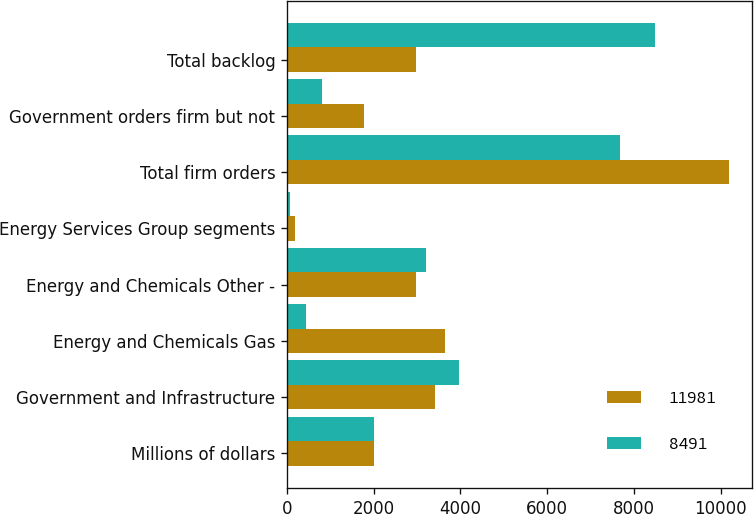Convert chart to OTSL. <chart><loc_0><loc_0><loc_500><loc_500><stacked_bar_chart><ecel><fcel>Millions of dollars<fcel>Government and Infrastructure<fcel>Energy and Chemicals Gas<fcel>Energy and Chemicals Other -<fcel>Energy Services Group segments<fcel>Total firm orders<fcel>Government orders firm but not<fcel>Total backlog<nl><fcel>11981<fcel>2005<fcel>3403<fcel>3651<fcel>2972<fcel>180<fcel>10206<fcel>1775<fcel>2972<nl><fcel>8491<fcel>2004<fcel>3968<fcel>443<fcel>3200<fcel>64<fcel>7675<fcel>816<fcel>8491<nl></chart> 